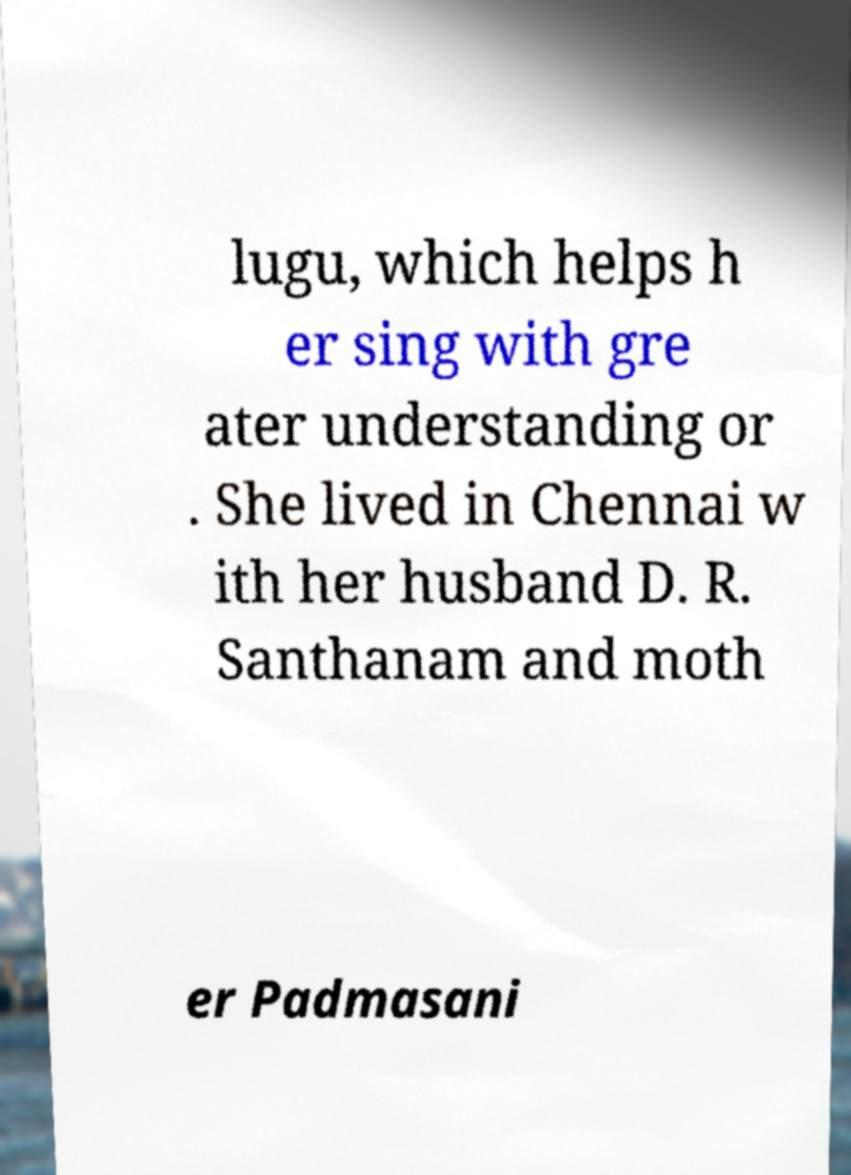Can you read and provide the text displayed in the image?This photo seems to have some interesting text. Can you extract and type it out for me? lugu, which helps h er sing with gre ater understanding or . She lived in Chennai w ith her husband D. R. Santhanam and moth er Padmasani 